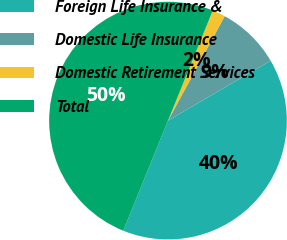Convert chart. <chart><loc_0><loc_0><loc_500><loc_500><pie_chart><fcel>Foreign Life Insurance &<fcel>Domestic Life Insurance<fcel>Domestic Retirement Services<fcel>Total<nl><fcel>39.55%<fcel>8.68%<fcel>1.77%<fcel>50.0%<nl></chart> 